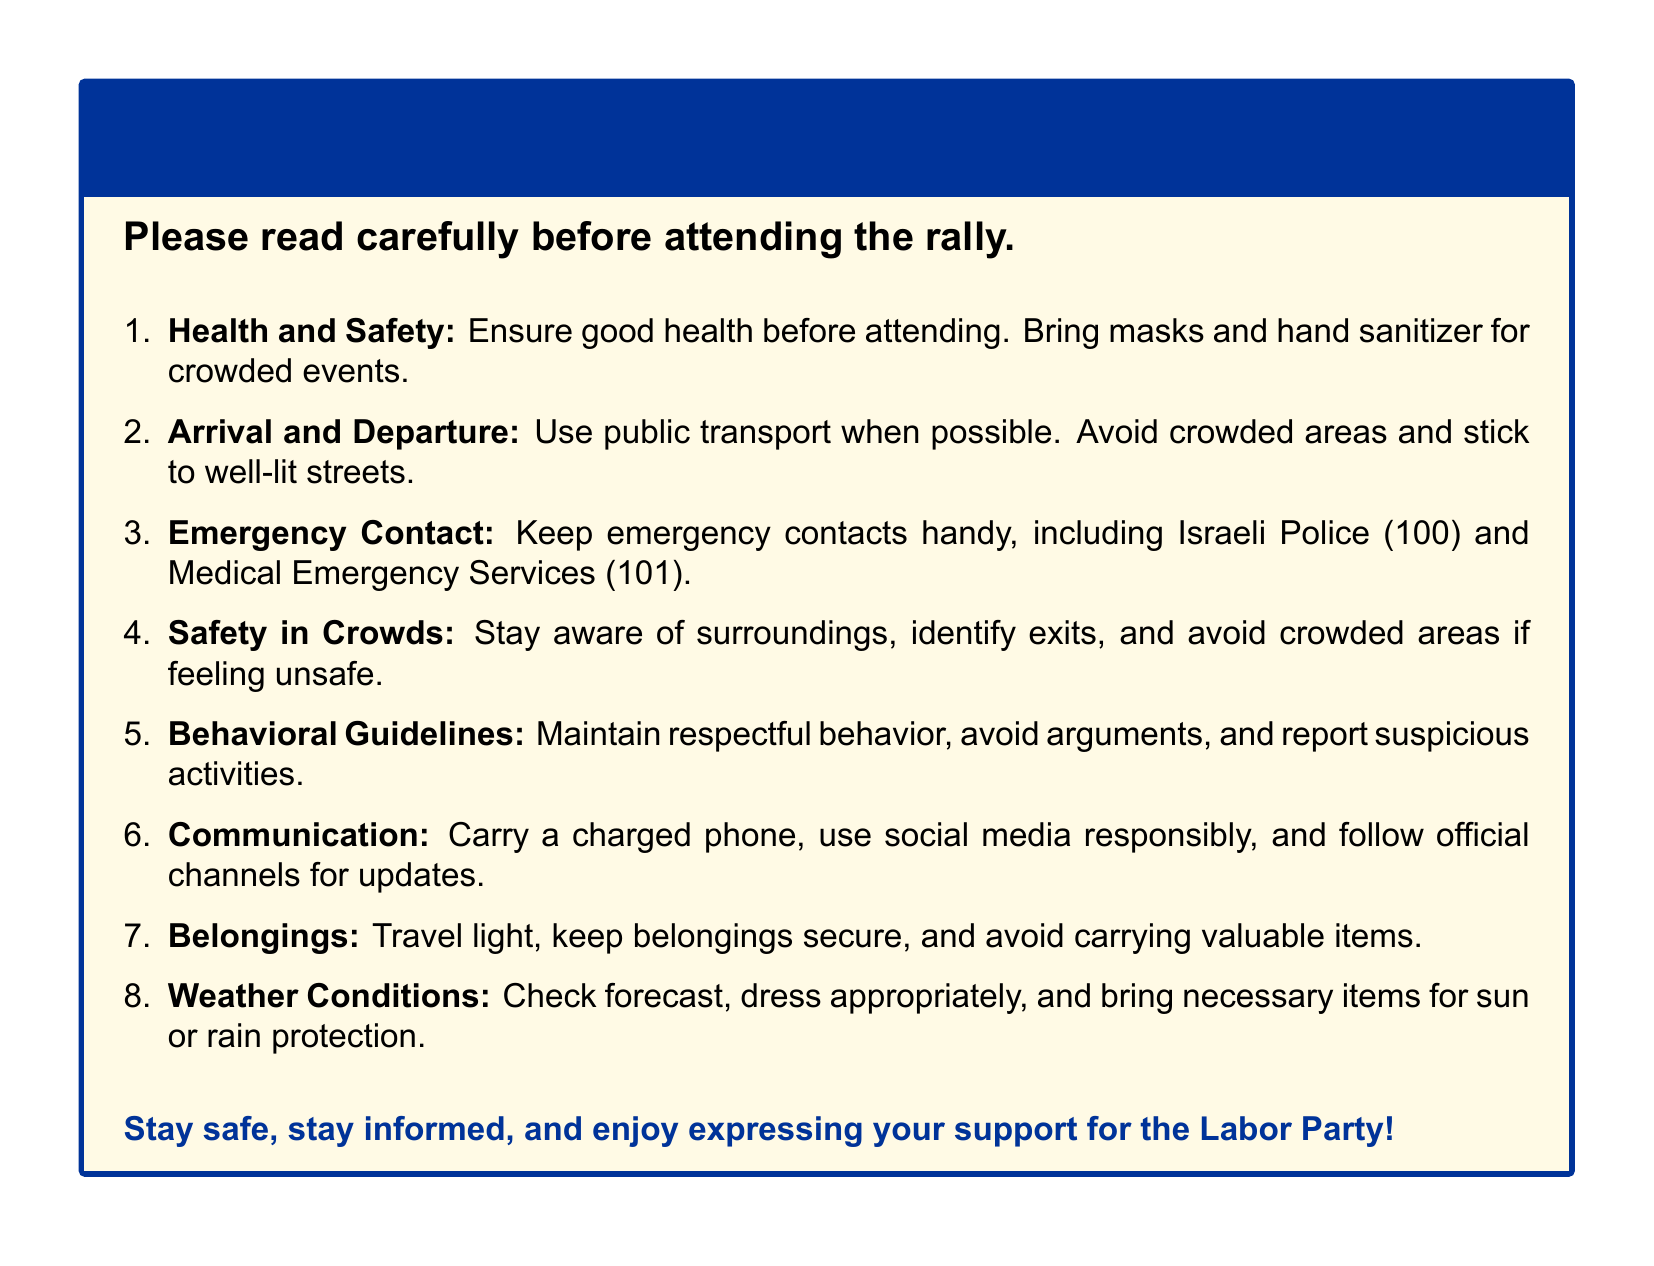What is the title of the document? The title is found in the first line of the rendered document, indicating the purpose of the instructions.
Answer: Safety Instructions for Political Rally Attendance - Labor Party Supporters What number should you call for medical emergencies? The document lists emergency contacts, including the specific number for medical emergencies.
Answer: 101 What should you bring to crowded events? The document mentions specific items to ensure health and safety while attending rallies.
Answer: Masks and hand sanitizer Which mode of transport is recommended? The document advises on optimal travel methods to ensure safety when attending the rally.
Answer: Public transport What should you do if you feel unsafe in a crowd? The document provides guidelines for personal safety in crowded situations.
Answer: Avoid crowded areas Name one type of behavior to maintain at the rally. The document establishes guidelines for expected behavior at the event for attendees.
Answer: Respectful behavior What should you check before dressing for the rally? The document suggests preparation regarding attire based on a specific condition.
Answer: Forecast What is advised regarding personal belongings? The document emphasizes securing items for safety during the rally.
Answer: Travel light and keep belongings secure 